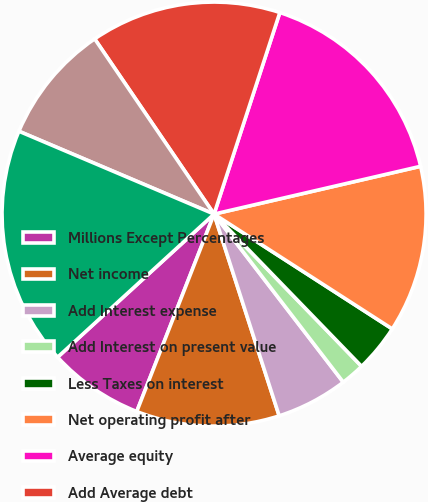Convert chart. <chart><loc_0><loc_0><loc_500><loc_500><pie_chart><fcel>Millions Except Percentages<fcel>Net income<fcel>Add Interest expense<fcel>Add Interest on present value<fcel>Less Taxes on interest<fcel>Net operating profit after<fcel>Average equity<fcel>Add Average debt<fcel>Add Average present value of<fcel>Average invested capital as<nl><fcel>7.27%<fcel>10.91%<fcel>5.46%<fcel>1.82%<fcel>3.64%<fcel>12.73%<fcel>16.36%<fcel>14.54%<fcel>9.09%<fcel>18.18%<nl></chart> 